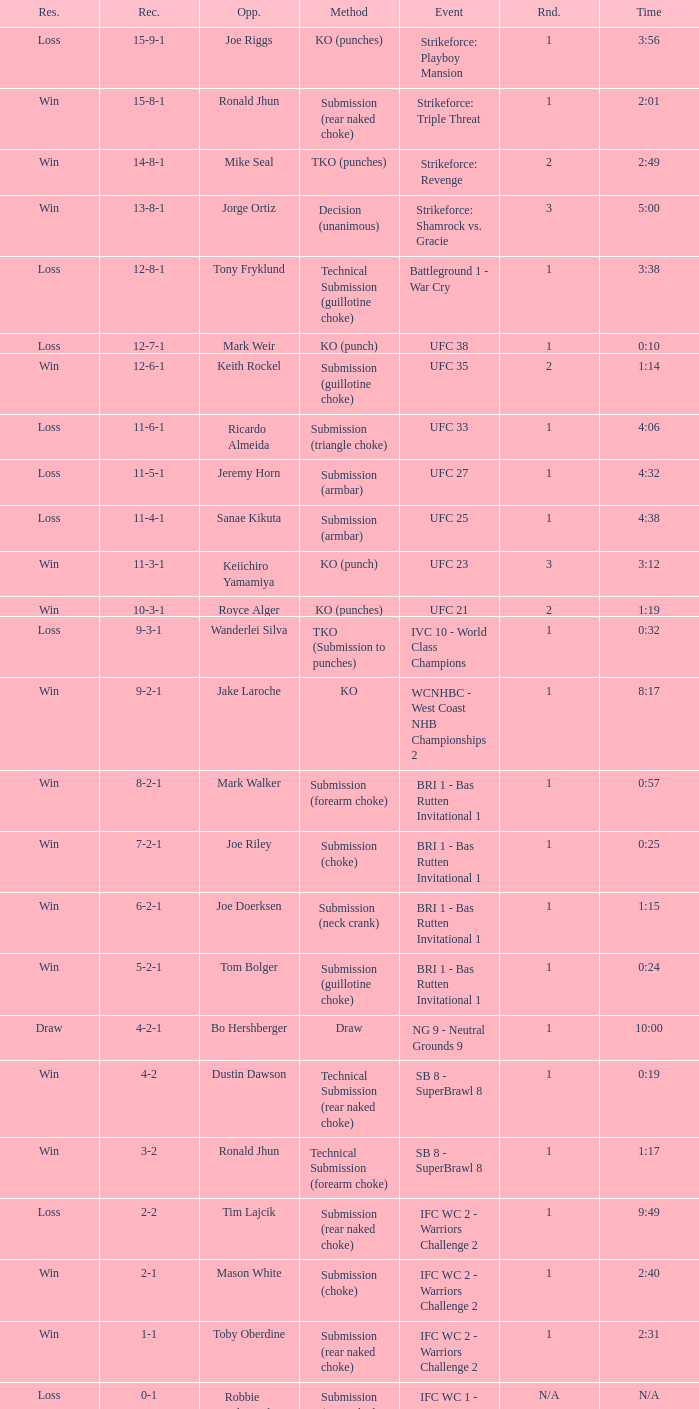What is the record during the event, UFC 27? 11-5-1. 